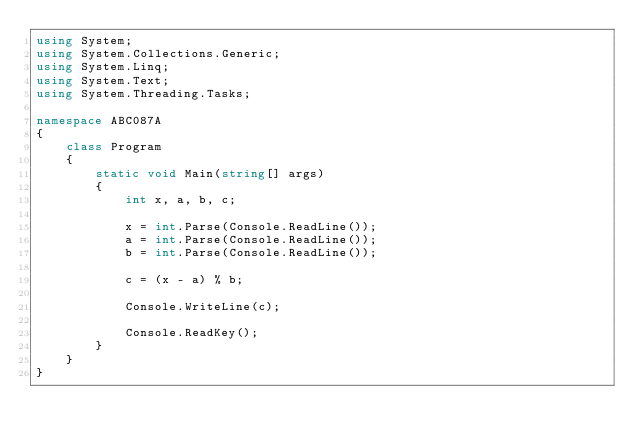<code> <loc_0><loc_0><loc_500><loc_500><_C#_>using System;
using System.Collections.Generic;
using System.Linq;
using System.Text;
using System.Threading.Tasks;

namespace ABC087A
{
    class Program
    {
        static void Main(string[] args)
        {
            int x, a, b, c;

            x = int.Parse(Console.ReadLine());
            a = int.Parse(Console.ReadLine());
            b = int.Parse(Console.ReadLine());

            c = (x - a) % b;

            Console.WriteLine(c);

            Console.ReadKey();
        }
    }
}
</code> 